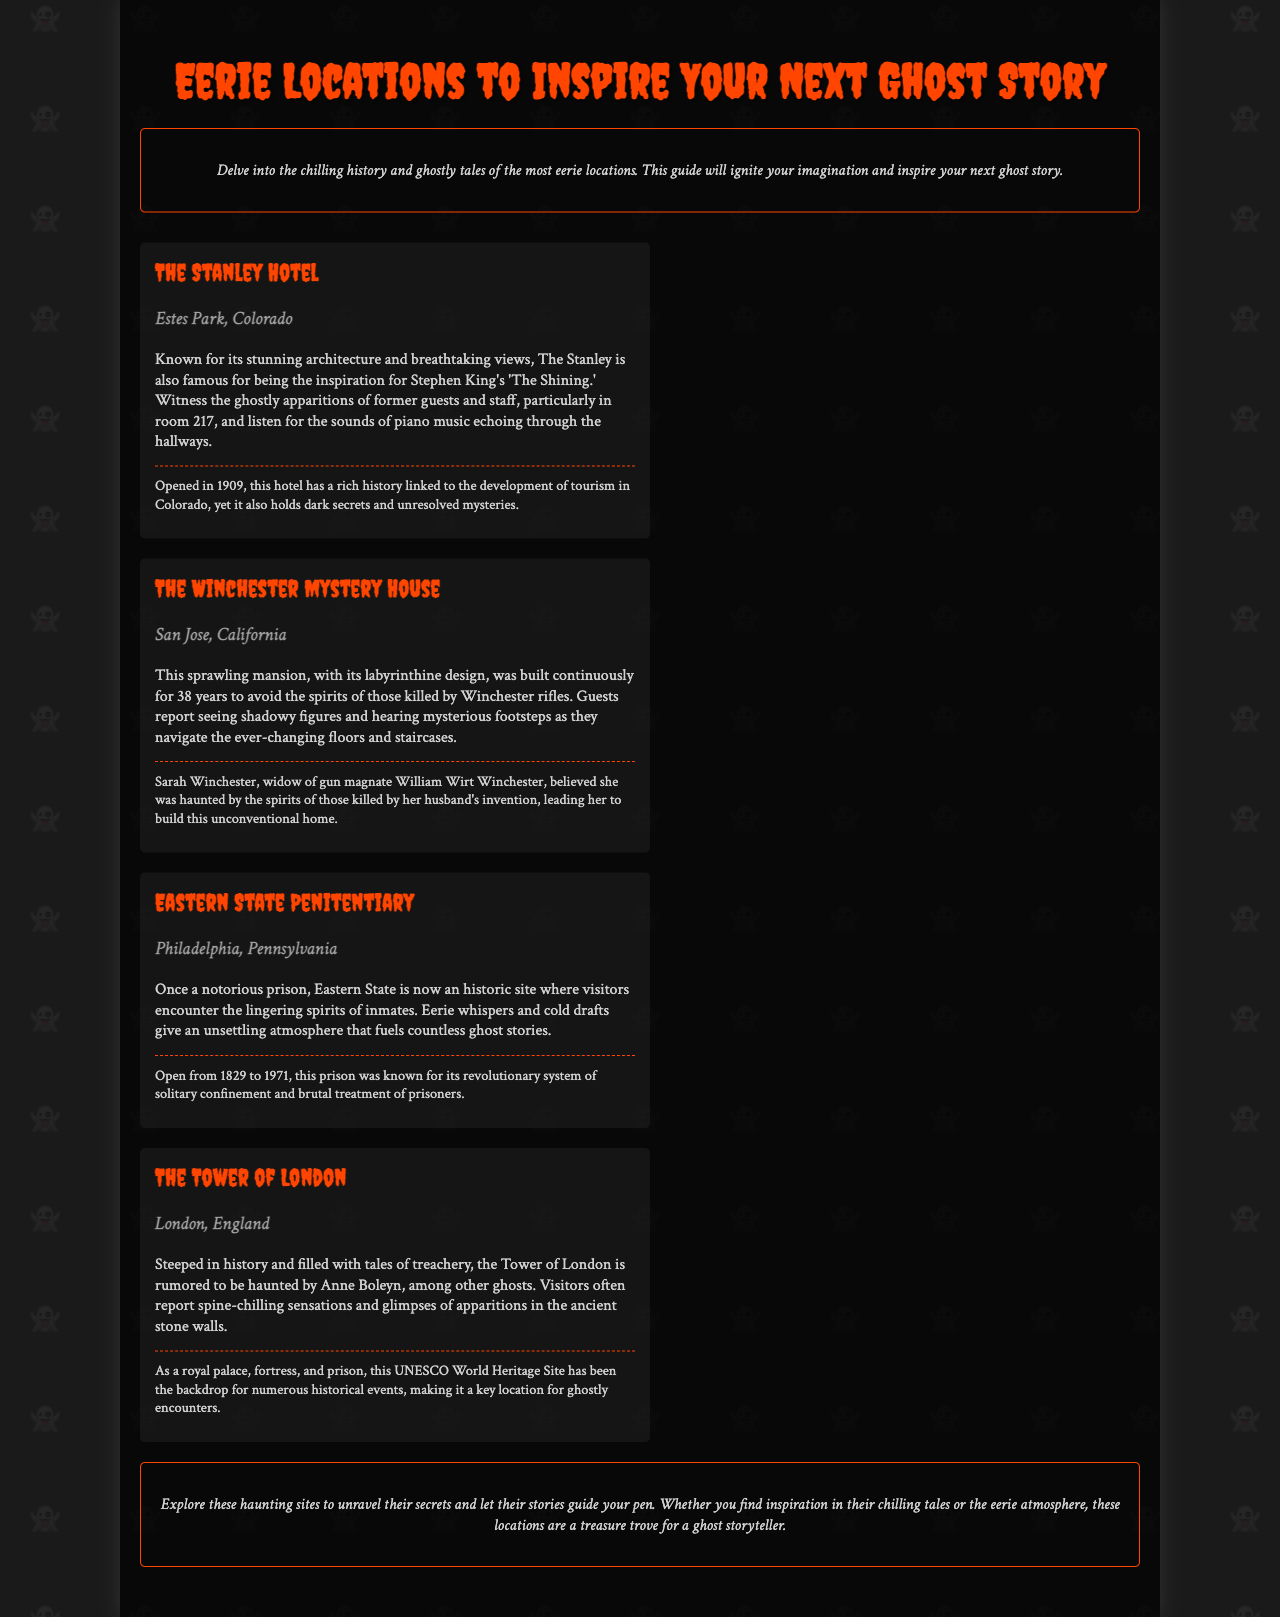What is the title of the brochure? The title is prominently displayed at the top of the brochure, stating the focus of the document.
Answer: Eerie Locations to Inspire Your Next Ghost Story Who is the author of 'The Shining'? The brochure mentions that The Stanley Hotel is the inspiration for this author's famous work.
Answer: Stephen King What year did The Stanley Hotel open? The historical context provided under The Stanley Hotel mentions its opening year.
Answer: 1909 Which location is described as having a labyrinthine design? The Winchester Mystery House is described with this characteristic in the brochure.
Answer: The Winchester Mystery House What notable figure is said to haunt the Tower of London? The brochure states that this figure is one of the famous ghosts associated with the historical location.
Answer: Anne Boleyn What type of site is Eastern State Penitentiary now? The current status of this location is detailed in its description in the document.
Answer: Historic site How many years was the Winchester Mystery House built continuously? The duration of the building period for this mansion is mentioned in its description.
Answer: 38 years What is the general theme of the brochure? The introduction outlines the main theme and purpose of the brochure.
Answer: Eerie locations and ghost stories What does the introduction encourage readers to do? The introduction lays out the purpose and inspiration readers should take from the document.
Answer: Ignite your imagination 